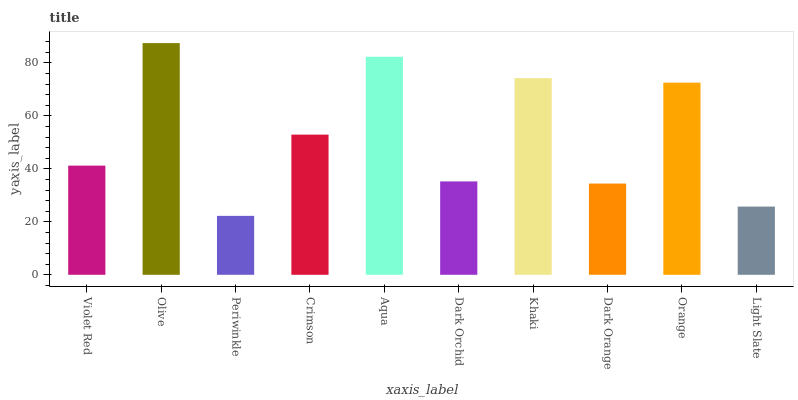Is Periwinkle the minimum?
Answer yes or no. Yes. Is Olive the maximum?
Answer yes or no. Yes. Is Olive the minimum?
Answer yes or no. No. Is Periwinkle the maximum?
Answer yes or no. No. Is Olive greater than Periwinkle?
Answer yes or no. Yes. Is Periwinkle less than Olive?
Answer yes or no. Yes. Is Periwinkle greater than Olive?
Answer yes or no. No. Is Olive less than Periwinkle?
Answer yes or no. No. Is Crimson the high median?
Answer yes or no. Yes. Is Violet Red the low median?
Answer yes or no. Yes. Is Light Slate the high median?
Answer yes or no. No. Is Light Slate the low median?
Answer yes or no. No. 